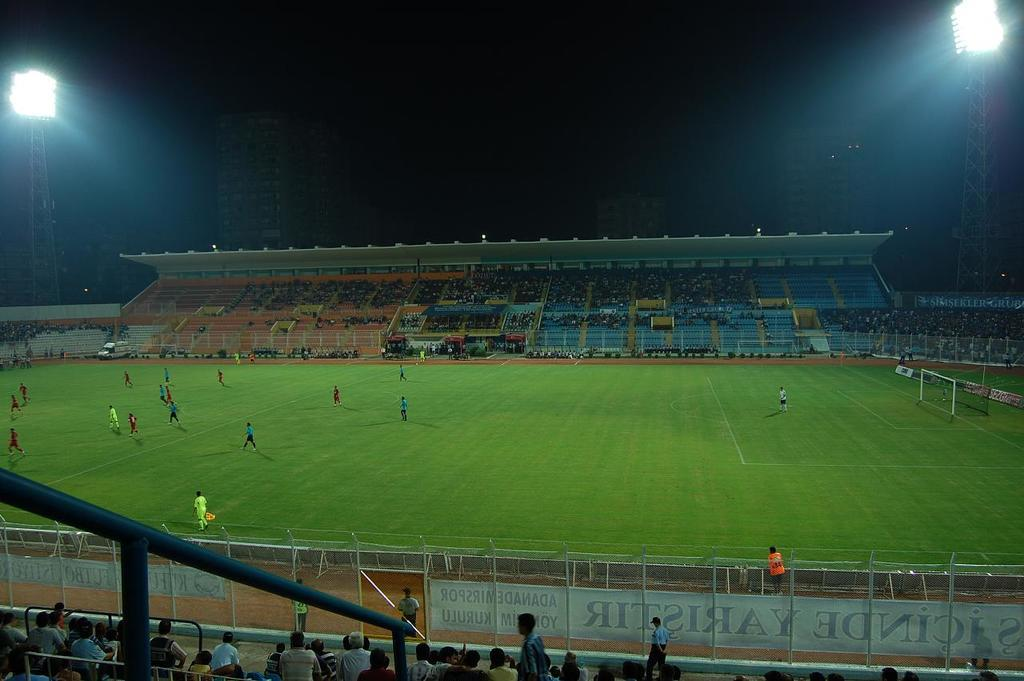What is the main subject in the middle of the picture? There is a football ground in the middle of the picture. What can be seen in the background of the picture? There is a stadium in the background of the picture. What are the tall structures on either side of the picture? There are flood lights on either side of the picture. Can you tell me how many bananas are hanging from the flood lights in the image? There are no bananas present in the image; the flood lights are not associated with any fruit. 